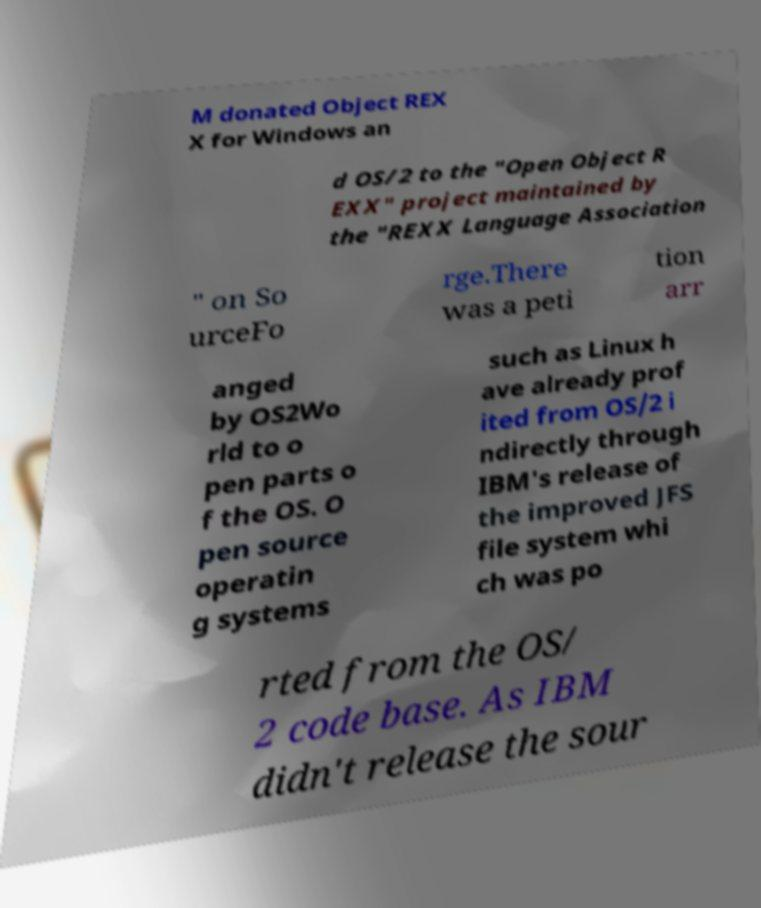For documentation purposes, I need the text within this image transcribed. Could you provide that? M donated Object REX X for Windows an d OS/2 to the "Open Object R EXX" project maintained by the "REXX Language Association " on So urceFo rge.There was a peti tion arr anged by OS2Wo rld to o pen parts o f the OS. O pen source operatin g systems such as Linux h ave already prof ited from OS/2 i ndirectly through IBM's release of the improved JFS file system whi ch was po rted from the OS/ 2 code base. As IBM didn't release the sour 